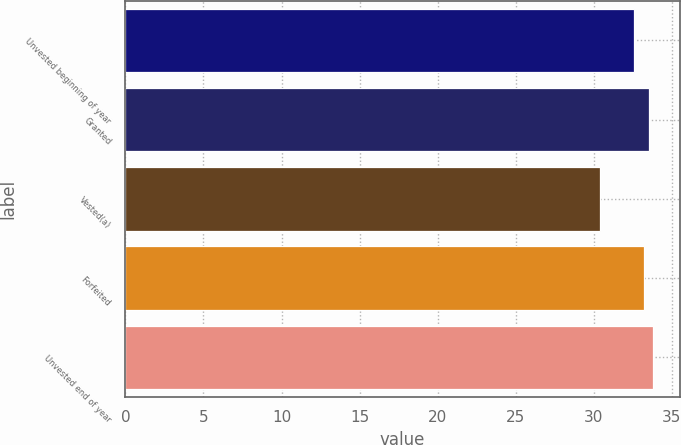<chart> <loc_0><loc_0><loc_500><loc_500><bar_chart><fcel>Unvested beginning of year<fcel>Granted<fcel>Vested(a)<fcel>Forfeited<fcel>Unvested end of year<nl><fcel>32.58<fcel>33.52<fcel>30.41<fcel>33.22<fcel>33.83<nl></chart> 